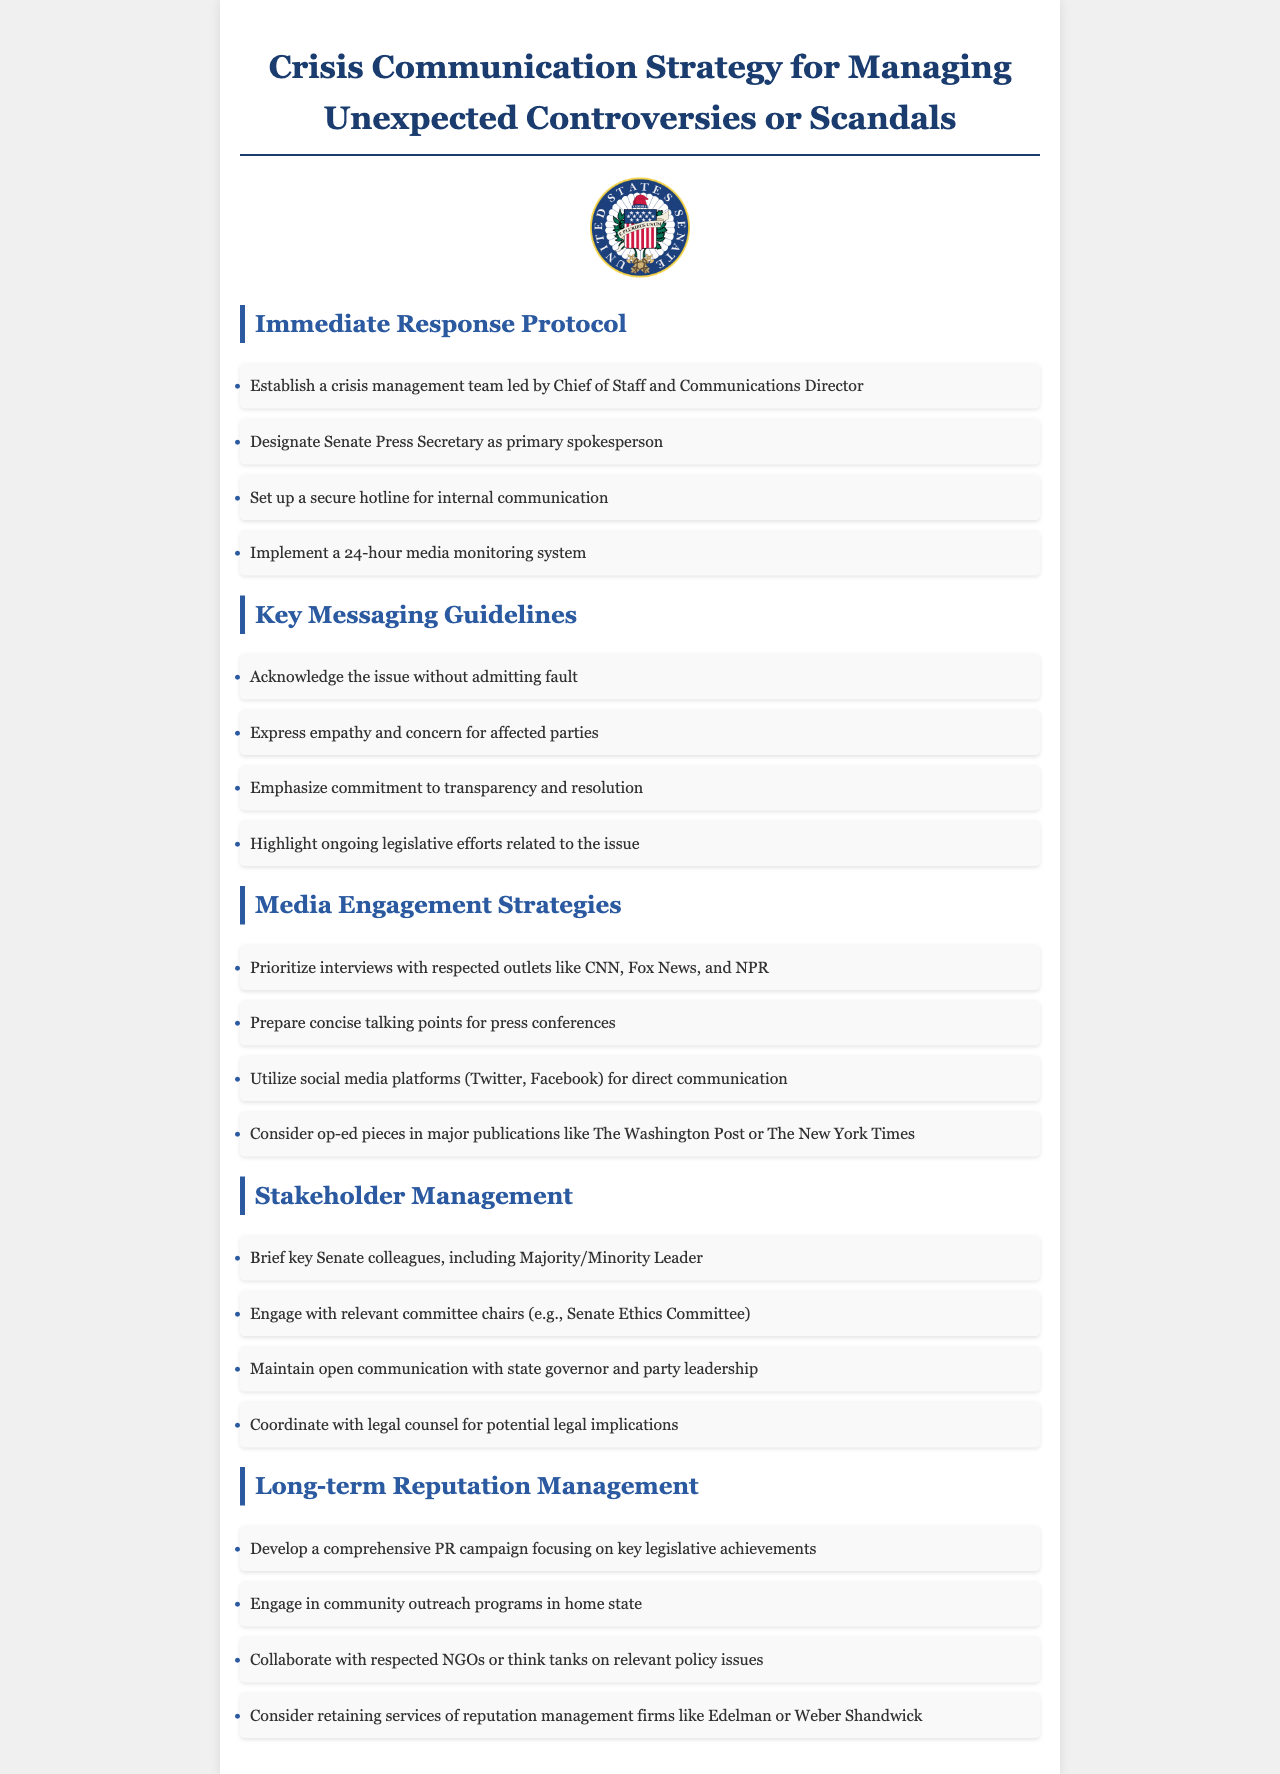What is the role of the Chief of Staff in the protocol? The Chief of Staff leads the crisis management team according to the Immediate Response Protocol.
Answer: Lead the crisis management team Who is designated as the primary spokesperson? The document specifies that the Senate Press Secretary is designated as the primary spokesperson.
Answer: Senate Press Secretary What type of system is implemented for media monitoring? A 24-hour media monitoring system is mentioned in the Immediate Response Protocol for effective management.
Answer: 24-hour media monitoring system How should the issue be acknowledged? It should be acknowledged without admitting fault according to the Key Messaging Guidelines.
Answer: Without admitting fault Which media outlets should be prioritized for interviews? Respected outlets like CNN, Fox News, and NPR should be prioritized for interviews, as noted in Media Engagement Strategies.
Answer: CNN, Fox News, NPR What is one of the long-term reputation management strategies? The document suggests developing a comprehensive PR campaign focusing on key legislative achievements for long-term reputation management.
Answer: Comprehensive PR campaign How many items are listed under Immediate Response Protocol? There are four items listed under Immediate Response Protocol, indicating the steps to take in a crisis.
Answer: Four Which committee is suggested for engagement in Stakeholder Management? The relevant committee chairs, specifically the Senate Ethics Committee, are suggested for engagement in Stakeholder Management.
Answer: Senate Ethics Committee 